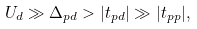Convert formula to latex. <formula><loc_0><loc_0><loc_500><loc_500>U _ { d } \gg \Delta _ { p d } > | t _ { p d } | \gg | t _ { p p } | ,</formula> 